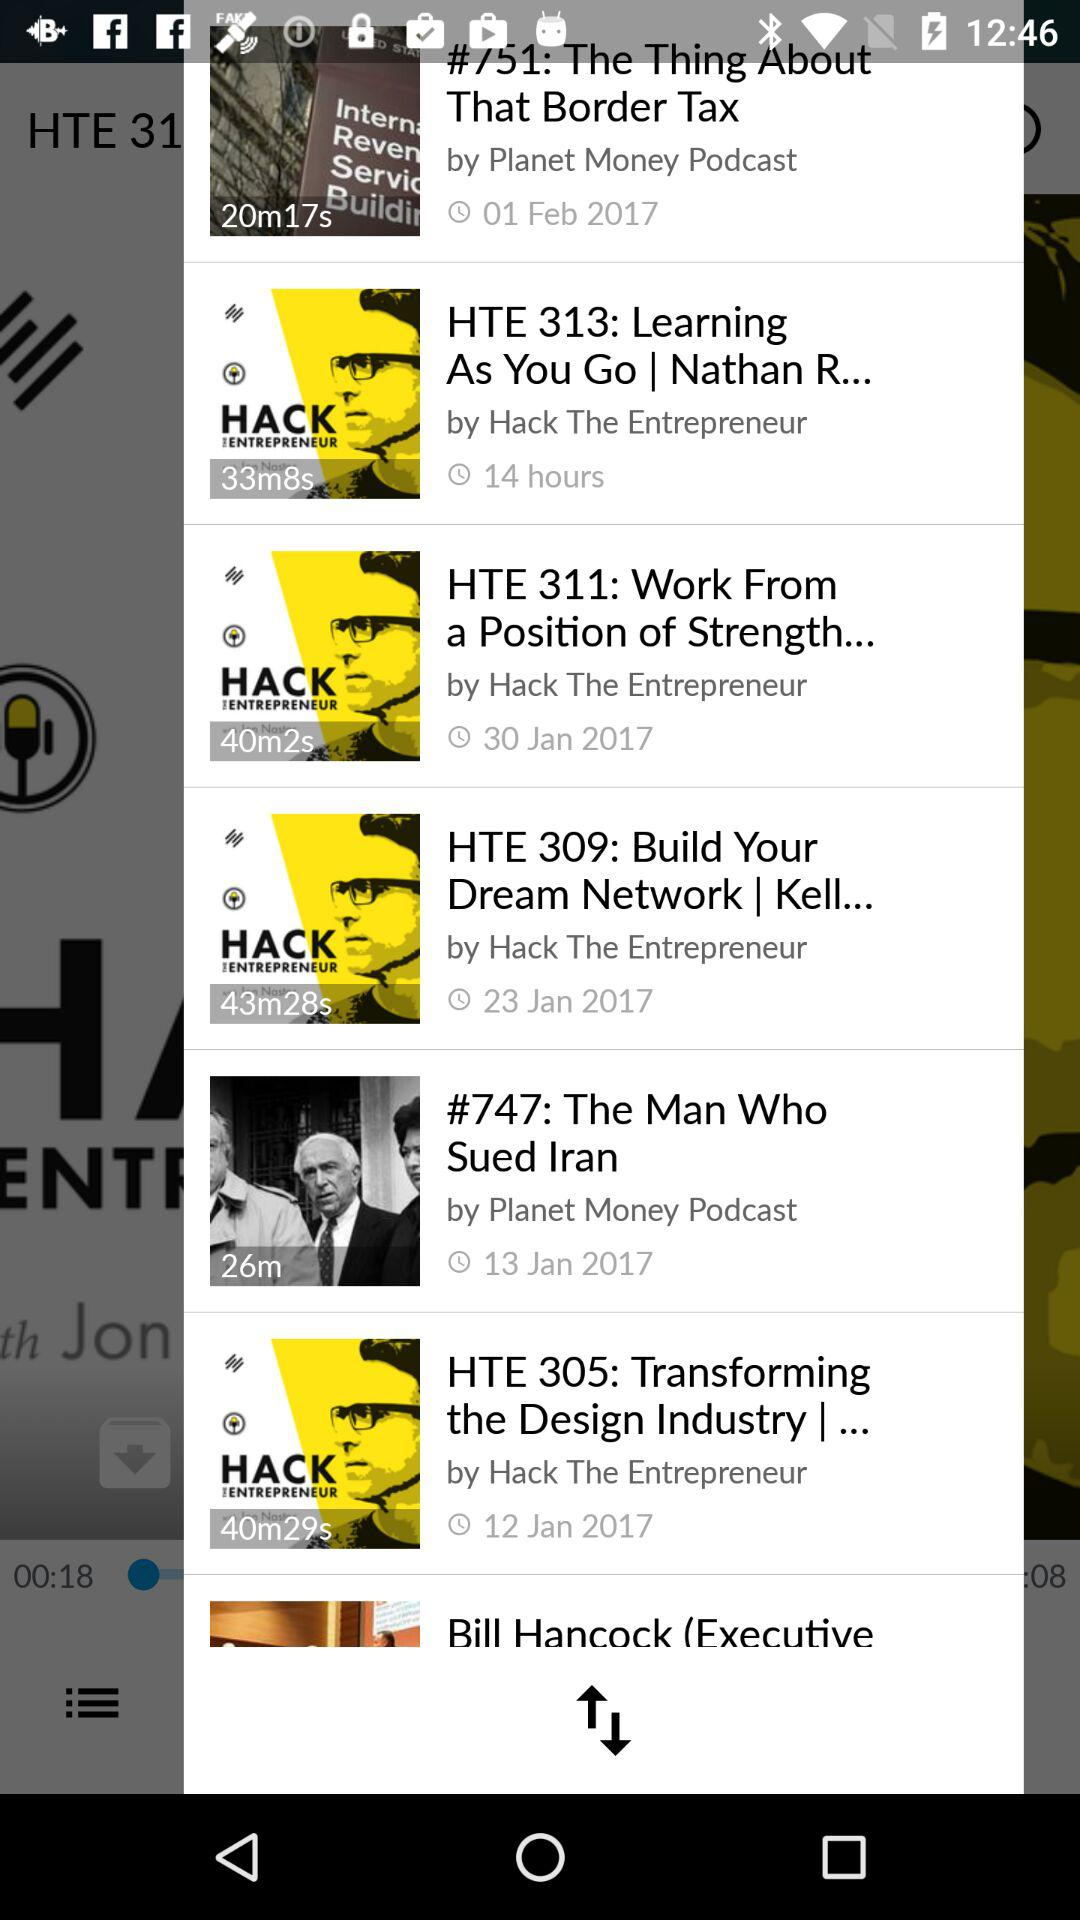Who is the creator of "The Man Who Sued Iran"? The creator is Planet Money Podcast. 